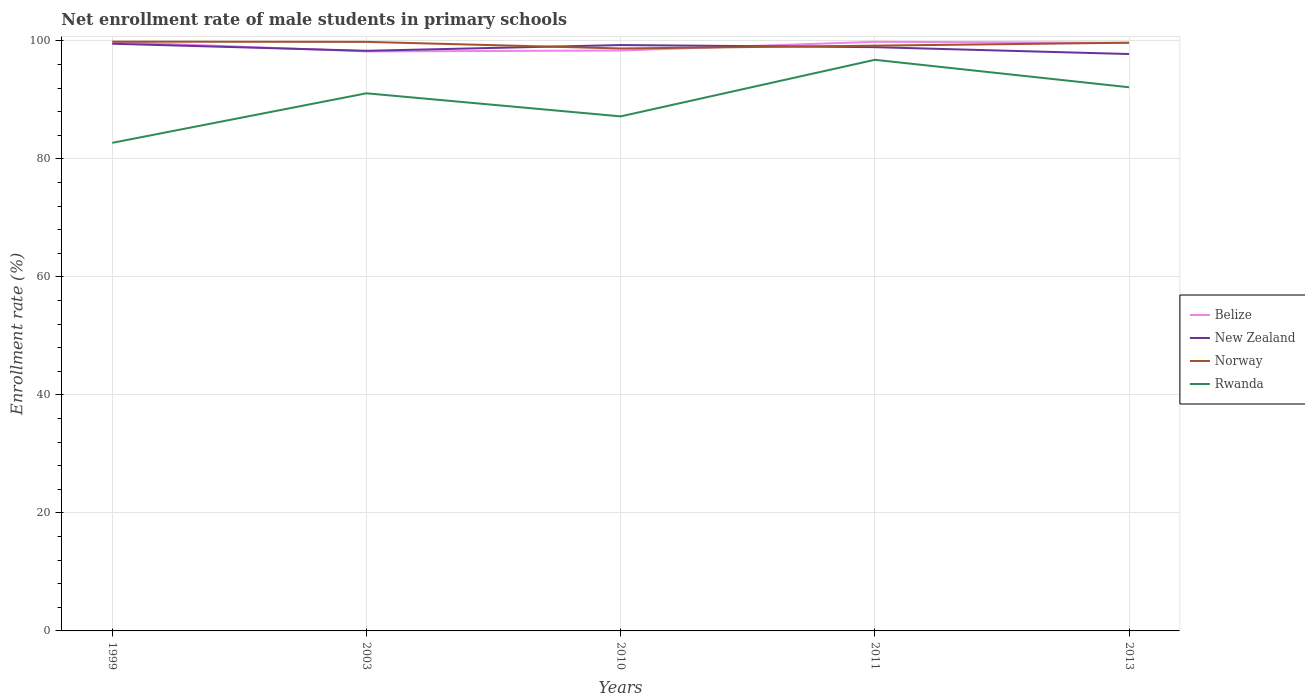How many different coloured lines are there?
Your answer should be very brief. 4. Is the number of lines equal to the number of legend labels?
Keep it short and to the point. Yes. Across all years, what is the maximum net enrollment rate of male students in primary schools in New Zealand?
Offer a terse response. 97.78. What is the total net enrollment rate of male students in primary schools in Belize in the graph?
Offer a very short reply. -1.63. What is the difference between the highest and the second highest net enrollment rate of male students in primary schools in New Zealand?
Keep it short and to the point. 1.75. What is the difference between the highest and the lowest net enrollment rate of male students in primary schools in Rwanda?
Make the answer very short. 3. Is the net enrollment rate of male students in primary schools in New Zealand strictly greater than the net enrollment rate of male students in primary schools in Belize over the years?
Offer a very short reply. No. How many years are there in the graph?
Provide a succinct answer. 5. What is the difference between two consecutive major ticks on the Y-axis?
Your response must be concise. 20. Does the graph contain any zero values?
Offer a very short reply. No. Where does the legend appear in the graph?
Offer a very short reply. Center right. How many legend labels are there?
Your answer should be very brief. 4. How are the legend labels stacked?
Your answer should be very brief. Vertical. What is the title of the graph?
Give a very brief answer. Net enrollment rate of male students in primary schools. What is the label or title of the Y-axis?
Give a very brief answer. Enrollment rate (%). What is the Enrollment rate (%) in Belize in 1999?
Ensure brevity in your answer.  99.83. What is the Enrollment rate (%) in New Zealand in 1999?
Give a very brief answer. 99.53. What is the Enrollment rate (%) in Norway in 1999?
Offer a very short reply. 99.88. What is the Enrollment rate (%) of Rwanda in 1999?
Provide a short and direct response. 82.73. What is the Enrollment rate (%) of Belize in 2003?
Keep it short and to the point. 98.22. What is the Enrollment rate (%) of New Zealand in 2003?
Your answer should be very brief. 98.33. What is the Enrollment rate (%) of Norway in 2003?
Keep it short and to the point. 99.84. What is the Enrollment rate (%) in Rwanda in 2003?
Your answer should be compact. 91.12. What is the Enrollment rate (%) of Belize in 2010?
Make the answer very short. 98.37. What is the Enrollment rate (%) in New Zealand in 2010?
Your response must be concise. 99.3. What is the Enrollment rate (%) of Norway in 2010?
Provide a succinct answer. 98.72. What is the Enrollment rate (%) of Rwanda in 2010?
Keep it short and to the point. 87.21. What is the Enrollment rate (%) of Belize in 2011?
Provide a short and direct response. 99.85. What is the Enrollment rate (%) of New Zealand in 2011?
Offer a terse response. 98.94. What is the Enrollment rate (%) of Norway in 2011?
Your answer should be compact. 99.2. What is the Enrollment rate (%) in Rwanda in 2011?
Give a very brief answer. 96.8. What is the Enrollment rate (%) in Belize in 2013?
Your response must be concise. 99.67. What is the Enrollment rate (%) in New Zealand in 2013?
Make the answer very short. 97.78. What is the Enrollment rate (%) of Norway in 2013?
Offer a very short reply. 99.7. What is the Enrollment rate (%) in Rwanda in 2013?
Ensure brevity in your answer.  92.15. Across all years, what is the maximum Enrollment rate (%) of Belize?
Your response must be concise. 99.85. Across all years, what is the maximum Enrollment rate (%) of New Zealand?
Keep it short and to the point. 99.53. Across all years, what is the maximum Enrollment rate (%) in Norway?
Offer a very short reply. 99.88. Across all years, what is the maximum Enrollment rate (%) in Rwanda?
Your answer should be very brief. 96.8. Across all years, what is the minimum Enrollment rate (%) of Belize?
Provide a succinct answer. 98.22. Across all years, what is the minimum Enrollment rate (%) in New Zealand?
Your answer should be very brief. 97.78. Across all years, what is the minimum Enrollment rate (%) in Norway?
Ensure brevity in your answer.  98.72. Across all years, what is the minimum Enrollment rate (%) in Rwanda?
Your response must be concise. 82.73. What is the total Enrollment rate (%) of Belize in the graph?
Make the answer very short. 495.95. What is the total Enrollment rate (%) in New Zealand in the graph?
Offer a very short reply. 493.88. What is the total Enrollment rate (%) in Norway in the graph?
Your answer should be compact. 497.34. What is the total Enrollment rate (%) of Rwanda in the graph?
Offer a very short reply. 450.01. What is the difference between the Enrollment rate (%) of Belize in 1999 and that in 2003?
Offer a very short reply. 1.61. What is the difference between the Enrollment rate (%) of New Zealand in 1999 and that in 2003?
Your answer should be compact. 1.2. What is the difference between the Enrollment rate (%) in Norway in 1999 and that in 2003?
Give a very brief answer. 0.04. What is the difference between the Enrollment rate (%) of Rwanda in 1999 and that in 2003?
Offer a terse response. -8.4. What is the difference between the Enrollment rate (%) of Belize in 1999 and that in 2010?
Provide a succinct answer. 1.46. What is the difference between the Enrollment rate (%) in New Zealand in 1999 and that in 2010?
Offer a very short reply. 0.23. What is the difference between the Enrollment rate (%) in Norway in 1999 and that in 2010?
Offer a terse response. 1.16. What is the difference between the Enrollment rate (%) in Rwanda in 1999 and that in 2010?
Your response must be concise. -4.48. What is the difference between the Enrollment rate (%) of Belize in 1999 and that in 2011?
Make the answer very short. -0.02. What is the difference between the Enrollment rate (%) in New Zealand in 1999 and that in 2011?
Offer a terse response. 0.58. What is the difference between the Enrollment rate (%) in Norway in 1999 and that in 2011?
Offer a very short reply. 0.68. What is the difference between the Enrollment rate (%) in Rwanda in 1999 and that in 2011?
Your answer should be very brief. -14.07. What is the difference between the Enrollment rate (%) in Belize in 1999 and that in 2013?
Keep it short and to the point. 0.17. What is the difference between the Enrollment rate (%) in New Zealand in 1999 and that in 2013?
Provide a short and direct response. 1.75. What is the difference between the Enrollment rate (%) in Norway in 1999 and that in 2013?
Your answer should be compact. 0.18. What is the difference between the Enrollment rate (%) in Rwanda in 1999 and that in 2013?
Your answer should be compact. -9.42. What is the difference between the Enrollment rate (%) of Belize in 2003 and that in 2010?
Offer a very short reply. -0.15. What is the difference between the Enrollment rate (%) of New Zealand in 2003 and that in 2010?
Keep it short and to the point. -0.97. What is the difference between the Enrollment rate (%) of Norway in 2003 and that in 2010?
Offer a very short reply. 1.12. What is the difference between the Enrollment rate (%) in Rwanda in 2003 and that in 2010?
Keep it short and to the point. 3.91. What is the difference between the Enrollment rate (%) of Belize in 2003 and that in 2011?
Your response must be concise. -1.63. What is the difference between the Enrollment rate (%) in New Zealand in 2003 and that in 2011?
Your response must be concise. -0.62. What is the difference between the Enrollment rate (%) of Norway in 2003 and that in 2011?
Your answer should be compact. 0.64. What is the difference between the Enrollment rate (%) of Rwanda in 2003 and that in 2011?
Offer a very short reply. -5.68. What is the difference between the Enrollment rate (%) in Belize in 2003 and that in 2013?
Ensure brevity in your answer.  -1.45. What is the difference between the Enrollment rate (%) in New Zealand in 2003 and that in 2013?
Provide a succinct answer. 0.55. What is the difference between the Enrollment rate (%) in Norway in 2003 and that in 2013?
Your answer should be compact. 0.14. What is the difference between the Enrollment rate (%) in Rwanda in 2003 and that in 2013?
Make the answer very short. -1.02. What is the difference between the Enrollment rate (%) of Belize in 2010 and that in 2011?
Ensure brevity in your answer.  -1.48. What is the difference between the Enrollment rate (%) in New Zealand in 2010 and that in 2011?
Make the answer very short. 0.36. What is the difference between the Enrollment rate (%) of Norway in 2010 and that in 2011?
Your response must be concise. -0.48. What is the difference between the Enrollment rate (%) in Rwanda in 2010 and that in 2011?
Keep it short and to the point. -9.59. What is the difference between the Enrollment rate (%) of Belize in 2010 and that in 2013?
Your answer should be very brief. -1.3. What is the difference between the Enrollment rate (%) of New Zealand in 2010 and that in 2013?
Keep it short and to the point. 1.52. What is the difference between the Enrollment rate (%) of Norway in 2010 and that in 2013?
Offer a very short reply. -0.98. What is the difference between the Enrollment rate (%) in Rwanda in 2010 and that in 2013?
Provide a short and direct response. -4.94. What is the difference between the Enrollment rate (%) of Belize in 2011 and that in 2013?
Keep it short and to the point. 0.18. What is the difference between the Enrollment rate (%) of New Zealand in 2011 and that in 2013?
Ensure brevity in your answer.  1.17. What is the difference between the Enrollment rate (%) of Norway in 2011 and that in 2013?
Your response must be concise. -0.5. What is the difference between the Enrollment rate (%) of Rwanda in 2011 and that in 2013?
Offer a very short reply. 4.65. What is the difference between the Enrollment rate (%) of Belize in 1999 and the Enrollment rate (%) of New Zealand in 2003?
Give a very brief answer. 1.51. What is the difference between the Enrollment rate (%) of Belize in 1999 and the Enrollment rate (%) of Norway in 2003?
Provide a succinct answer. -0.01. What is the difference between the Enrollment rate (%) of Belize in 1999 and the Enrollment rate (%) of Rwanda in 2003?
Make the answer very short. 8.71. What is the difference between the Enrollment rate (%) of New Zealand in 1999 and the Enrollment rate (%) of Norway in 2003?
Provide a succinct answer. -0.31. What is the difference between the Enrollment rate (%) of New Zealand in 1999 and the Enrollment rate (%) of Rwanda in 2003?
Your response must be concise. 8.4. What is the difference between the Enrollment rate (%) of Norway in 1999 and the Enrollment rate (%) of Rwanda in 2003?
Keep it short and to the point. 8.76. What is the difference between the Enrollment rate (%) of Belize in 1999 and the Enrollment rate (%) of New Zealand in 2010?
Keep it short and to the point. 0.53. What is the difference between the Enrollment rate (%) in Belize in 1999 and the Enrollment rate (%) in Norway in 2010?
Offer a very short reply. 1.11. What is the difference between the Enrollment rate (%) in Belize in 1999 and the Enrollment rate (%) in Rwanda in 2010?
Your response must be concise. 12.62. What is the difference between the Enrollment rate (%) of New Zealand in 1999 and the Enrollment rate (%) of Norway in 2010?
Your response must be concise. 0.81. What is the difference between the Enrollment rate (%) of New Zealand in 1999 and the Enrollment rate (%) of Rwanda in 2010?
Keep it short and to the point. 12.32. What is the difference between the Enrollment rate (%) in Norway in 1999 and the Enrollment rate (%) in Rwanda in 2010?
Give a very brief answer. 12.67. What is the difference between the Enrollment rate (%) of Belize in 1999 and the Enrollment rate (%) of New Zealand in 2011?
Keep it short and to the point. 0.89. What is the difference between the Enrollment rate (%) in Belize in 1999 and the Enrollment rate (%) in Norway in 2011?
Provide a succinct answer. 0.63. What is the difference between the Enrollment rate (%) of Belize in 1999 and the Enrollment rate (%) of Rwanda in 2011?
Your answer should be compact. 3.03. What is the difference between the Enrollment rate (%) of New Zealand in 1999 and the Enrollment rate (%) of Norway in 2011?
Your response must be concise. 0.33. What is the difference between the Enrollment rate (%) in New Zealand in 1999 and the Enrollment rate (%) in Rwanda in 2011?
Your answer should be compact. 2.73. What is the difference between the Enrollment rate (%) of Norway in 1999 and the Enrollment rate (%) of Rwanda in 2011?
Your response must be concise. 3.08. What is the difference between the Enrollment rate (%) of Belize in 1999 and the Enrollment rate (%) of New Zealand in 2013?
Provide a short and direct response. 2.06. What is the difference between the Enrollment rate (%) of Belize in 1999 and the Enrollment rate (%) of Norway in 2013?
Your response must be concise. 0.13. What is the difference between the Enrollment rate (%) in Belize in 1999 and the Enrollment rate (%) in Rwanda in 2013?
Your response must be concise. 7.69. What is the difference between the Enrollment rate (%) in New Zealand in 1999 and the Enrollment rate (%) in Norway in 2013?
Provide a short and direct response. -0.17. What is the difference between the Enrollment rate (%) in New Zealand in 1999 and the Enrollment rate (%) in Rwanda in 2013?
Your answer should be very brief. 7.38. What is the difference between the Enrollment rate (%) of Norway in 1999 and the Enrollment rate (%) of Rwanda in 2013?
Keep it short and to the point. 7.73. What is the difference between the Enrollment rate (%) in Belize in 2003 and the Enrollment rate (%) in New Zealand in 2010?
Your response must be concise. -1.08. What is the difference between the Enrollment rate (%) of Belize in 2003 and the Enrollment rate (%) of Norway in 2010?
Provide a short and direct response. -0.5. What is the difference between the Enrollment rate (%) of Belize in 2003 and the Enrollment rate (%) of Rwanda in 2010?
Your answer should be very brief. 11.01. What is the difference between the Enrollment rate (%) of New Zealand in 2003 and the Enrollment rate (%) of Norway in 2010?
Your response must be concise. -0.4. What is the difference between the Enrollment rate (%) of New Zealand in 2003 and the Enrollment rate (%) of Rwanda in 2010?
Provide a succinct answer. 11.11. What is the difference between the Enrollment rate (%) in Norway in 2003 and the Enrollment rate (%) in Rwanda in 2010?
Offer a terse response. 12.63. What is the difference between the Enrollment rate (%) of Belize in 2003 and the Enrollment rate (%) of New Zealand in 2011?
Provide a short and direct response. -0.72. What is the difference between the Enrollment rate (%) in Belize in 2003 and the Enrollment rate (%) in Norway in 2011?
Offer a very short reply. -0.98. What is the difference between the Enrollment rate (%) of Belize in 2003 and the Enrollment rate (%) of Rwanda in 2011?
Offer a very short reply. 1.42. What is the difference between the Enrollment rate (%) of New Zealand in 2003 and the Enrollment rate (%) of Norway in 2011?
Offer a terse response. -0.87. What is the difference between the Enrollment rate (%) of New Zealand in 2003 and the Enrollment rate (%) of Rwanda in 2011?
Your answer should be compact. 1.53. What is the difference between the Enrollment rate (%) of Norway in 2003 and the Enrollment rate (%) of Rwanda in 2011?
Your response must be concise. 3.04. What is the difference between the Enrollment rate (%) in Belize in 2003 and the Enrollment rate (%) in New Zealand in 2013?
Offer a terse response. 0.44. What is the difference between the Enrollment rate (%) in Belize in 2003 and the Enrollment rate (%) in Norway in 2013?
Provide a succinct answer. -1.48. What is the difference between the Enrollment rate (%) of Belize in 2003 and the Enrollment rate (%) of Rwanda in 2013?
Offer a terse response. 6.08. What is the difference between the Enrollment rate (%) of New Zealand in 2003 and the Enrollment rate (%) of Norway in 2013?
Your answer should be very brief. -1.37. What is the difference between the Enrollment rate (%) of New Zealand in 2003 and the Enrollment rate (%) of Rwanda in 2013?
Offer a terse response. 6.18. What is the difference between the Enrollment rate (%) of Norway in 2003 and the Enrollment rate (%) of Rwanda in 2013?
Give a very brief answer. 7.69. What is the difference between the Enrollment rate (%) in Belize in 2010 and the Enrollment rate (%) in New Zealand in 2011?
Your answer should be compact. -0.57. What is the difference between the Enrollment rate (%) in Belize in 2010 and the Enrollment rate (%) in Norway in 2011?
Offer a terse response. -0.83. What is the difference between the Enrollment rate (%) of Belize in 2010 and the Enrollment rate (%) of Rwanda in 2011?
Your answer should be compact. 1.57. What is the difference between the Enrollment rate (%) of New Zealand in 2010 and the Enrollment rate (%) of Norway in 2011?
Keep it short and to the point. 0.1. What is the difference between the Enrollment rate (%) in New Zealand in 2010 and the Enrollment rate (%) in Rwanda in 2011?
Make the answer very short. 2.5. What is the difference between the Enrollment rate (%) of Norway in 2010 and the Enrollment rate (%) of Rwanda in 2011?
Keep it short and to the point. 1.92. What is the difference between the Enrollment rate (%) of Belize in 2010 and the Enrollment rate (%) of New Zealand in 2013?
Offer a terse response. 0.59. What is the difference between the Enrollment rate (%) of Belize in 2010 and the Enrollment rate (%) of Norway in 2013?
Make the answer very short. -1.33. What is the difference between the Enrollment rate (%) in Belize in 2010 and the Enrollment rate (%) in Rwanda in 2013?
Your answer should be very brief. 6.23. What is the difference between the Enrollment rate (%) in New Zealand in 2010 and the Enrollment rate (%) in Norway in 2013?
Give a very brief answer. -0.4. What is the difference between the Enrollment rate (%) of New Zealand in 2010 and the Enrollment rate (%) of Rwanda in 2013?
Keep it short and to the point. 7.15. What is the difference between the Enrollment rate (%) in Norway in 2010 and the Enrollment rate (%) in Rwanda in 2013?
Your answer should be compact. 6.58. What is the difference between the Enrollment rate (%) in Belize in 2011 and the Enrollment rate (%) in New Zealand in 2013?
Your response must be concise. 2.08. What is the difference between the Enrollment rate (%) of Belize in 2011 and the Enrollment rate (%) of Norway in 2013?
Provide a short and direct response. 0.15. What is the difference between the Enrollment rate (%) of Belize in 2011 and the Enrollment rate (%) of Rwanda in 2013?
Keep it short and to the point. 7.71. What is the difference between the Enrollment rate (%) of New Zealand in 2011 and the Enrollment rate (%) of Norway in 2013?
Ensure brevity in your answer.  -0.76. What is the difference between the Enrollment rate (%) of New Zealand in 2011 and the Enrollment rate (%) of Rwanda in 2013?
Your answer should be compact. 6.8. What is the difference between the Enrollment rate (%) of Norway in 2011 and the Enrollment rate (%) of Rwanda in 2013?
Offer a very short reply. 7.05. What is the average Enrollment rate (%) of Belize per year?
Your answer should be very brief. 99.19. What is the average Enrollment rate (%) in New Zealand per year?
Offer a terse response. 98.78. What is the average Enrollment rate (%) in Norway per year?
Make the answer very short. 99.47. What is the average Enrollment rate (%) in Rwanda per year?
Your answer should be compact. 90. In the year 1999, what is the difference between the Enrollment rate (%) of Belize and Enrollment rate (%) of New Zealand?
Provide a short and direct response. 0.31. In the year 1999, what is the difference between the Enrollment rate (%) of Belize and Enrollment rate (%) of Norway?
Offer a terse response. -0.05. In the year 1999, what is the difference between the Enrollment rate (%) of Belize and Enrollment rate (%) of Rwanda?
Make the answer very short. 17.11. In the year 1999, what is the difference between the Enrollment rate (%) of New Zealand and Enrollment rate (%) of Norway?
Provide a short and direct response. -0.35. In the year 1999, what is the difference between the Enrollment rate (%) of New Zealand and Enrollment rate (%) of Rwanda?
Provide a succinct answer. 16.8. In the year 1999, what is the difference between the Enrollment rate (%) of Norway and Enrollment rate (%) of Rwanda?
Make the answer very short. 17.15. In the year 2003, what is the difference between the Enrollment rate (%) of Belize and Enrollment rate (%) of New Zealand?
Offer a terse response. -0.1. In the year 2003, what is the difference between the Enrollment rate (%) in Belize and Enrollment rate (%) in Norway?
Make the answer very short. -1.62. In the year 2003, what is the difference between the Enrollment rate (%) of Belize and Enrollment rate (%) of Rwanda?
Ensure brevity in your answer.  7.1. In the year 2003, what is the difference between the Enrollment rate (%) of New Zealand and Enrollment rate (%) of Norway?
Offer a very short reply. -1.51. In the year 2003, what is the difference between the Enrollment rate (%) in New Zealand and Enrollment rate (%) in Rwanda?
Provide a short and direct response. 7.2. In the year 2003, what is the difference between the Enrollment rate (%) in Norway and Enrollment rate (%) in Rwanda?
Your response must be concise. 8.72. In the year 2010, what is the difference between the Enrollment rate (%) in Belize and Enrollment rate (%) in New Zealand?
Give a very brief answer. -0.93. In the year 2010, what is the difference between the Enrollment rate (%) in Belize and Enrollment rate (%) in Norway?
Your answer should be very brief. -0.35. In the year 2010, what is the difference between the Enrollment rate (%) of Belize and Enrollment rate (%) of Rwanda?
Provide a succinct answer. 11.16. In the year 2010, what is the difference between the Enrollment rate (%) in New Zealand and Enrollment rate (%) in Norway?
Give a very brief answer. 0.58. In the year 2010, what is the difference between the Enrollment rate (%) in New Zealand and Enrollment rate (%) in Rwanda?
Keep it short and to the point. 12.09. In the year 2010, what is the difference between the Enrollment rate (%) of Norway and Enrollment rate (%) of Rwanda?
Your response must be concise. 11.51. In the year 2011, what is the difference between the Enrollment rate (%) in Belize and Enrollment rate (%) in New Zealand?
Your answer should be very brief. 0.91. In the year 2011, what is the difference between the Enrollment rate (%) in Belize and Enrollment rate (%) in Norway?
Provide a short and direct response. 0.65. In the year 2011, what is the difference between the Enrollment rate (%) of Belize and Enrollment rate (%) of Rwanda?
Ensure brevity in your answer.  3.05. In the year 2011, what is the difference between the Enrollment rate (%) of New Zealand and Enrollment rate (%) of Norway?
Provide a short and direct response. -0.25. In the year 2011, what is the difference between the Enrollment rate (%) of New Zealand and Enrollment rate (%) of Rwanda?
Offer a very short reply. 2.14. In the year 2011, what is the difference between the Enrollment rate (%) of Norway and Enrollment rate (%) of Rwanda?
Your answer should be compact. 2.4. In the year 2013, what is the difference between the Enrollment rate (%) of Belize and Enrollment rate (%) of New Zealand?
Keep it short and to the point. 1.89. In the year 2013, what is the difference between the Enrollment rate (%) in Belize and Enrollment rate (%) in Norway?
Ensure brevity in your answer.  -0.03. In the year 2013, what is the difference between the Enrollment rate (%) in Belize and Enrollment rate (%) in Rwanda?
Your response must be concise. 7.52. In the year 2013, what is the difference between the Enrollment rate (%) of New Zealand and Enrollment rate (%) of Norway?
Keep it short and to the point. -1.92. In the year 2013, what is the difference between the Enrollment rate (%) in New Zealand and Enrollment rate (%) in Rwanda?
Your response must be concise. 5.63. In the year 2013, what is the difference between the Enrollment rate (%) in Norway and Enrollment rate (%) in Rwanda?
Ensure brevity in your answer.  7.55. What is the ratio of the Enrollment rate (%) in Belize in 1999 to that in 2003?
Make the answer very short. 1.02. What is the ratio of the Enrollment rate (%) of New Zealand in 1999 to that in 2003?
Your response must be concise. 1.01. What is the ratio of the Enrollment rate (%) of Norway in 1999 to that in 2003?
Offer a terse response. 1. What is the ratio of the Enrollment rate (%) in Rwanda in 1999 to that in 2003?
Provide a succinct answer. 0.91. What is the ratio of the Enrollment rate (%) of Belize in 1999 to that in 2010?
Ensure brevity in your answer.  1.01. What is the ratio of the Enrollment rate (%) of New Zealand in 1999 to that in 2010?
Keep it short and to the point. 1. What is the ratio of the Enrollment rate (%) in Norway in 1999 to that in 2010?
Provide a succinct answer. 1.01. What is the ratio of the Enrollment rate (%) in Rwanda in 1999 to that in 2010?
Give a very brief answer. 0.95. What is the ratio of the Enrollment rate (%) in New Zealand in 1999 to that in 2011?
Provide a succinct answer. 1.01. What is the ratio of the Enrollment rate (%) of Rwanda in 1999 to that in 2011?
Offer a very short reply. 0.85. What is the ratio of the Enrollment rate (%) in Belize in 1999 to that in 2013?
Give a very brief answer. 1. What is the ratio of the Enrollment rate (%) of New Zealand in 1999 to that in 2013?
Provide a succinct answer. 1.02. What is the ratio of the Enrollment rate (%) of Norway in 1999 to that in 2013?
Your response must be concise. 1. What is the ratio of the Enrollment rate (%) of Rwanda in 1999 to that in 2013?
Provide a succinct answer. 0.9. What is the ratio of the Enrollment rate (%) in Belize in 2003 to that in 2010?
Give a very brief answer. 1. What is the ratio of the Enrollment rate (%) of New Zealand in 2003 to that in 2010?
Make the answer very short. 0.99. What is the ratio of the Enrollment rate (%) in Norway in 2003 to that in 2010?
Provide a short and direct response. 1.01. What is the ratio of the Enrollment rate (%) of Rwanda in 2003 to that in 2010?
Make the answer very short. 1.04. What is the ratio of the Enrollment rate (%) in Belize in 2003 to that in 2011?
Your response must be concise. 0.98. What is the ratio of the Enrollment rate (%) of New Zealand in 2003 to that in 2011?
Ensure brevity in your answer.  0.99. What is the ratio of the Enrollment rate (%) in Norway in 2003 to that in 2011?
Make the answer very short. 1.01. What is the ratio of the Enrollment rate (%) in Rwanda in 2003 to that in 2011?
Your response must be concise. 0.94. What is the ratio of the Enrollment rate (%) in Belize in 2003 to that in 2013?
Make the answer very short. 0.99. What is the ratio of the Enrollment rate (%) in New Zealand in 2003 to that in 2013?
Make the answer very short. 1.01. What is the ratio of the Enrollment rate (%) in Norway in 2003 to that in 2013?
Offer a terse response. 1. What is the ratio of the Enrollment rate (%) of Rwanda in 2003 to that in 2013?
Give a very brief answer. 0.99. What is the ratio of the Enrollment rate (%) in Belize in 2010 to that in 2011?
Ensure brevity in your answer.  0.99. What is the ratio of the Enrollment rate (%) in New Zealand in 2010 to that in 2011?
Provide a short and direct response. 1. What is the ratio of the Enrollment rate (%) in Rwanda in 2010 to that in 2011?
Ensure brevity in your answer.  0.9. What is the ratio of the Enrollment rate (%) in New Zealand in 2010 to that in 2013?
Ensure brevity in your answer.  1.02. What is the ratio of the Enrollment rate (%) in Norway in 2010 to that in 2013?
Your answer should be compact. 0.99. What is the ratio of the Enrollment rate (%) in Rwanda in 2010 to that in 2013?
Provide a short and direct response. 0.95. What is the ratio of the Enrollment rate (%) of Belize in 2011 to that in 2013?
Offer a terse response. 1. What is the ratio of the Enrollment rate (%) of New Zealand in 2011 to that in 2013?
Provide a short and direct response. 1.01. What is the ratio of the Enrollment rate (%) in Norway in 2011 to that in 2013?
Ensure brevity in your answer.  0.99. What is the ratio of the Enrollment rate (%) in Rwanda in 2011 to that in 2013?
Make the answer very short. 1.05. What is the difference between the highest and the second highest Enrollment rate (%) in Belize?
Keep it short and to the point. 0.02. What is the difference between the highest and the second highest Enrollment rate (%) in New Zealand?
Your answer should be compact. 0.23. What is the difference between the highest and the second highest Enrollment rate (%) in Norway?
Make the answer very short. 0.04. What is the difference between the highest and the second highest Enrollment rate (%) in Rwanda?
Give a very brief answer. 4.65. What is the difference between the highest and the lowest Enrollment rate (%) of Belize?
Give a very brief answer. 1.63. What is the difference between the highest and the lowest Enrollment rate (%) in New Zealand?
Your response must be concise. 1.75. What is the difference between the highest and the lowest Enrollment rate (%) in Norway?
Make the answer very short. 1.16. What is the difference between the highest and the lowest Enrollment rate (%) of Rwanda?
Keep it short and to the point. 14.07. 